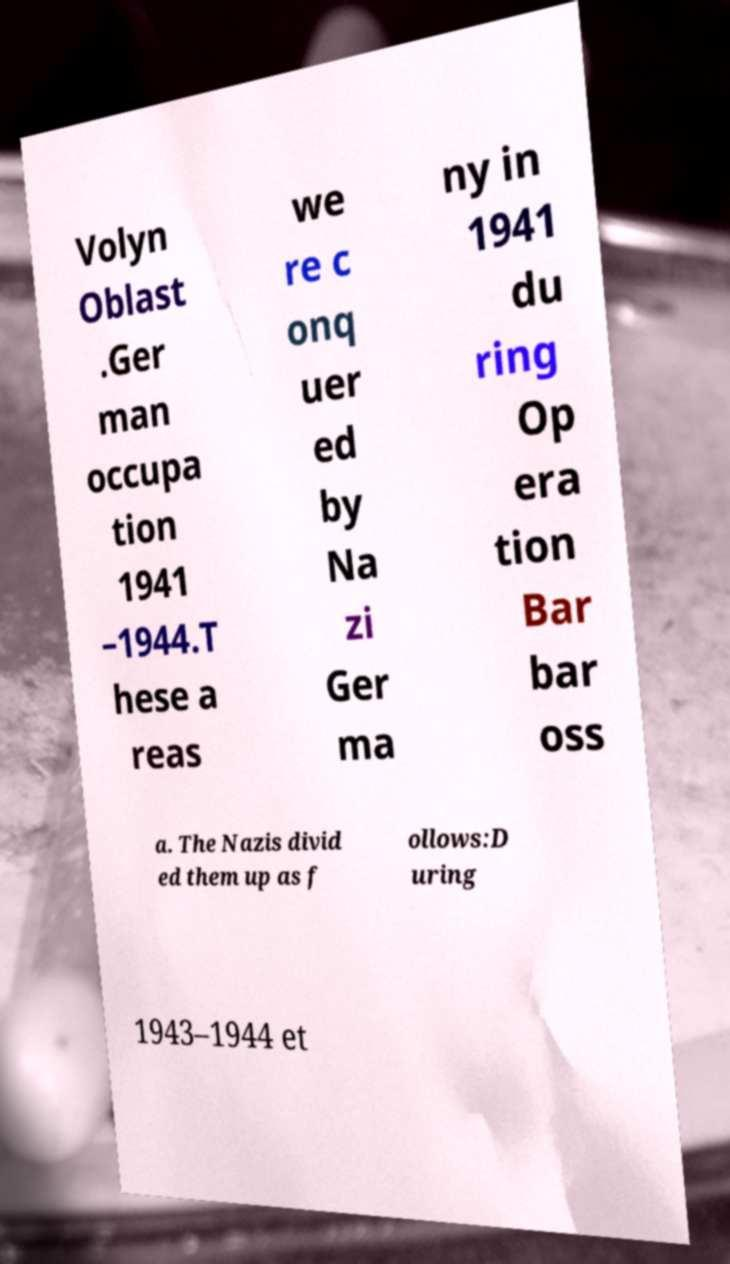For documentation purposes, I need the text within this image transcribed. Could you provide that? Volyn Oblast .Ger man occupa tion 1941 –1944.T hese a reas we re c onq uer ed by Na zi Ger ma ny in 1941 du ring Op era tion Bar bar oss a. The Nazis divid ed them up as f ollows:D uring 1943–1944 et 